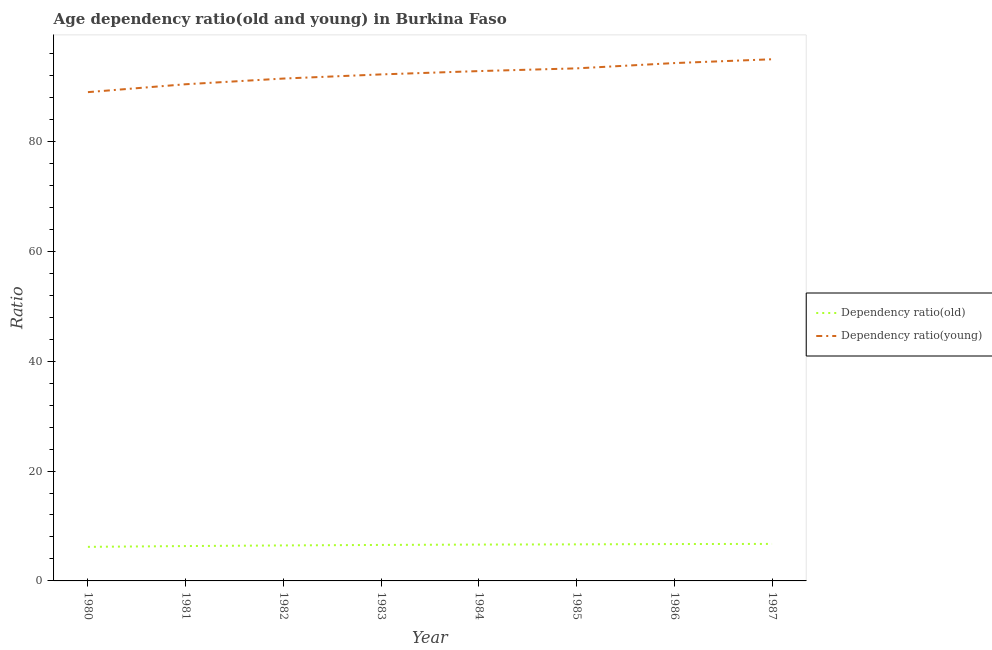Does the line corresponding to age dependency ratio(old) intersect with the line corresponding to age dependency ratio(young)?
Your answer should be very brief. No. Is the number of lines equal to the number of legend labels?
Provide a succinct answer. Yes. What is the age dependency ratio(young) in 1980?
Keep it short and to the point. 88.95. Across all years, what is the maximum age dependency ratio(young)?
Give a very brief answer. 94.94. Across all years, what is the minimum age dependency ratio(young)?
Your answer should be very brief. 88.95. In which year was the age dependency ratio(old) maximum?
Your answer should be very brief. 1987. What is the total age dependency ratio(old) in the graph?
Ensure brevity in your answer.  52.27. What is the difference between the age dependency ratio(young) in 1981 and that in 1984?
Your answer should be compact. -2.4. What is the difference between the age dependency ratio(young) in 1984 and the age dependency ratio(old) in 1987?
Offer a very short reply. 86.05. What is the average age dependency ratio(young) per year?
Your answer should be compact. 92.27. In the year 1980, what is the difference between the age dependency ratio(old) and age dependency ratio(young)?
Your answer should be compact. -82.75. In how many years, is the age dependency ratio(young) greater than 64?
Offer a terse response. 8. What is the ratio of the age dependency ratio(old) in 1983 to that in 1987?
Offer a very short reply. 0.97. Is the age dependency ratio(old) in 1980 less than that in 1984?
Your response must be concise. Yes. What is the difference between the highest and the second highest age dependency ratio(young)?
Your answer should be very brief. 0.69. What is the difference between the highest and the lowest age dependency ratio(young)?
Your answer should be compact. 5.98. In how many years, is the age dependency ratio(old) greater than the average age dependency ratio(old) taken over all years?
Offer a very short reply. 5. Does the age dependency ratio(old) monotonically increase over the years?
Your answer should be very brief. Yes. Is the age dependency ratio(old) strictly greater than the age dependency ratio(young) over the years?
Offer a very short reply. No. How many lines are there?
Offer a terse response. 2. How many years are there in the graph?
Give a very brief answer. 8. Does the graph contain grids?
Provide a short and direct response. No. Where does the legend appear in the graph?
Provide a short and direct response. Center right. How many legend labels are there?
Ensure brevity in your answer.  2. How are the legend labels stacked?
Your answer should be compact. Vertical. What is the title of the graph?
Your answer should be very brief. Age dependency ratio(old and young) in Burkina Faso. Does "GDP" appear as one of the legend labels in the graph?
Provide a succinct answer. No. What is the label or title of the X-axis?
Offer a very short reply. Year. What is the label or title of the Y-axis?
Provide a succinct answer. Ratio. What is the Ratio in Dependency ratio(old) in 1980?
Ensure brevity in your answer.  6.2. What is the Ratio of Dependency ratio(young) in 1980?
Offer a very short reply. 88.95. What is the Ratio in Dependency ratio(old) in 1981?
Your response must be concise. 6.34. What is the Ratio in Dependency ratio(young) in 1981?
Make the answer very short. 90.39. What is the Ratio in Dependency ratio(old) in 1982?
Keep it short and to the point. 6.46. What is the Ratio of Dependency ratio(young) in 1982?
Offer a very short reply. 91.42. What is the Ratio in Dependency ratio(old) in 1983?
Your answer should be very brief. 6.55. What is the Ratio of Dependency ratio(young) in 1983?
Your answer should be compact. 92.18. What is the Ratio of Dependency ratio(old) in 1984?
Keep it short and to the point. 6.61. What is the Ratio of Dependency ratio(young) in 1984?
Make the answer very short. 92.78. What is the Ratio of Dependency ratio(old) in 1985?
Your response must be concise. 6.65. What is the Ratio in Dependency ratio(young) in 1985?
Give a very brief answer. 93.28. What is the Ratio in Dependency ratio(old) in 1986?
Offer a terse response. 6.71. What is the Ratio in Dependency ratio(young) in 1986?
Provide a succinct answer. 94.24. What is the Ratio in Dependency ratio(old) in 1987?
Ensure brevity in your answer.  6.74. What is the Ratio of Dependency ratio(young) in 1987?
Your answer should be compact. 94.94. Across all years, what is the maximum Ratio of Dependency ratio(old)?
Ensure brevity in your answer.  6.74. Across all years, what is the maximum Ratio in Dependency ratio(young)?
Your answer should be compact. 94.94. Across all years, what is the minimum Ratio of Dependency ratio(old)?
Make the answer very short. 6.2. Across all years, what is the minimum Ratio in Dependency ratio(young)?
Provide a succinct answer. 88.95. What is the total Ratio in Dependency ratio(old) in the graph?
Provide a succinct answer. 52.27. What is the total Ratio of Dependency ratio(young) in the graph?
Your answer should be compact. 738.19. What is the difference between the Ratio in Dependency ratio(old) in 1980 and that in 1981?
Offer a very short reply. -0.14. What is the difference between the Ratio in Dependency ratio(young) in 1980 and that in 1981?
Make the answer very short. -1.44. What is the difference between the Ratio in Dependency ratio(old) in 1980 and that in 1982?
Give a very brief answer. -0.26. What is the difference between the Ratio of Dependency ratio(young) in 1980 and that in 1982?
Give a very brief answer. -2.47. What is the difference between the Ratio of Dependency ratio(old) in 1980 and that in 1983?
Provide a succinct answer. -0.35. What is the difference between the Ratio in Dependency ratio(young) in 1980 and that in 1983?
Keep it short and to the point. -3.23. What is the difference between the Ratio in Dependency ratio(old) in 1980 and that in 1984?
Provide a short and direct response. -0.41. What is the difference between the Ratio of Dependency ratio(young) in 1980 and that in 1984?
Keep it short and to the point. -3.83. What is the difference between the Ratio in Dependency ratio(old) in 1980 and that in 1985?
Offer a terse response. -0.45. What is the difference between the Ratio in Dependency ratio(young) in 1980 and that in 1985?
Provide a succinct answer. -4.33. What is the difference between the Ratio in Dependency ratio(old) in 1980 and that in 1986?
Offer a terse response. -0.51. What is the difference between the Ratio of Dependency ratio(young) in 1980 and that in 1986?
Offer a very short reply. -5.29. What is the difference between the Ratio of Dependency ratio(old) in 1980 and that in 1987?
Your answer should be very brief. -0.54. What is the difference between the Ratio of Dependency ratio(young) in 1980 and that in 1987?
Ensure brevity in your answer.  -5.98. What is the difference between the Ratio in Dependency ratio(old) in 1981 and that in 1982?
Your answer should be compact. -0.12. What is the difference between the Ratio in Dependency ratio(young) in 1981 and that in 1982?
Provide a succinct answer. -1.04. What is the difference between the Ratio in Dependency ratio(old) in 1981 and that in 1983?
Provide a succinct answer. -0.21. What is the difference between the Ratio in Dependency ratio(young) in 1981 and that in 1983?
Offer a very short reply. -1.79. What is the difference between the Ratio of Dependency ratio(old) in 1981 and that in 1984?
Your response must be concise. -0.27. What is the difference between the Ratio of Dependency ratio(young) in 1981 and that in 1984?
Offer a very short reply. -2.4. What is the difference between the Ratio in Dependency ratio(old) in 1981 and that in 1985?
Your answer should be compact. -0.31. What is the difference between the Ratio of Dependency ratio(young) in 1981 and that in 1985?
Provide a short and direct response. -2.89. What is the difference between the Ratio of Dependency ratio(old) in 1981 and that in 1986?
Your answer should be compact. -0.37. What is the difference between the Ratio in Dependency ratio(young) in 1981 and that in 1986?
Keep it short and to the point. -3.85. What is the difference between the Ratio in Dependency ratio(old) in 1981 and that in 1987?
Provide a succinct answer. -0.39. What is the difference between the Ratio in Dependency ratio(young) in 1981 and that in 1987?
Provide a succinct answer. -4.55. What is the difference between the Ratio of Dependency ratio(old) in 1982 and that in 1983?
Offer a terse response. -0.09. What is the difference between the Ratio in Dependency ratio(young) in 1982 and that in 1983?
Make the answer very short. -0.76. What is the difference between the Ratio in Dependency ratio(old) in 1982 and that in 1984?
Your response must be concise. -0.15. What is the difference between the Ratio of Dependency ratio(young) in 1982 and that in 1984?
Your answer should be very brief. -1.36. What is the difference between the Ratio of Dependency ratio(old) in 1982 and that in 1985?
Provide a short and direct response. -0.19. What is the difference between the Ratio of Dependency ratio(young) in 1982 and that in 1985?
Offer a very short reply. -1.86. What is the difference between the Ratio of Dependency ratio(old) in 1982 and that in 1986?
Offer a very short reply. -0.25. What is the difference between the Ratio in Dependency ratio(young) in 1982 and that in 1986?
Give a very brief answer. -2.82. What is the difference between the Ratio of Dependency ratio(old) in 1982 and that in 1987?
Offer a very short reply. -0.28. What is the difference between the Ratio of Dependency ratio(young) in 1982 and that in 1987?
Offer a terse response. -3.51. What is the difference between the Ratio of Dependency ratio(old) in 1983 and that in 1984?
Give a very brief answer. -0.06. What is the difference between the Ratio of Dependency ratio(young) in 1983 and that in 1984?
Provide a succinct answer. -0.6. What is the difference between the Ratio of Dependency ratio(old) in 1983 and that in 1985?
Your answer should be compact. -0.11. What is the difference between the Ratio of Dependency ratio(young) in 1983 and that in 1985?
Your answer should be very brief. -1.1. What is the difference between the Ratio of Dependency ratio(old) in 1983 and that in 1986?
Provide a short and direct response. -0.16. What is the difference between the Ratio in Dependency ratio(young) in 1983 and that in 1986?
Ensure brevity in your answer.  -2.06. What is the difference between the Ratio in Dependency ratio(old) in 1983 and that in 1987?
Make the answer very short. -0.19. What is the difference between the Ratio of Dependency ratio(young) in 1983 and that in 1987?
Your answer should be compact. -2.76. What is the difference between the Ratio of Dependency ratio(old) in 1984 and that in 1985?
Your answer should be very brief. -0.04. What is the difference between the Ratio of Dependency ratio(young) in 1984 and that in 1985?
Give a very brief answer. -0.5. What is the difference between the Ratio in Dependency ratio(old) in 1984 and that in 1986?
Your answer should be compact. -0.1. What is the difference between the Ratio of Dependency ratio(young) in 1984 and that in 1986?
Offer a terse response. -1.46. What is the difference between the Ratio in Dependency ratio(old) in 1984 and that in 1987?
Give a very brief answer. -0.12. What is the difference between the Ratio in Dependency ratio(young) in 1984 and that in 1987?
Ensure brevity in your answer.  -2.15. What is the difference between the Ratio of Dependency ratio(old) in 1985 and that in 1986?
Offer a terse response. -0.06. What is the difference between the Ratio of Dependency ratio(young) in 1985 and that in 1986?
Offer a terse response. -0.96. What is the difference between the Ratio of Dependency ratio(old) in 1985 and that in 1987?
Give a very brief answer. -0.08. What is the difference between the Ratio of Dependency ratio(young) in 1985 and that in 1987?
Make the answer very short. -1.66. What is the difference between the Ratio of Dependency ratio(old) in 1986 and that in 1987?
Provide a succinct answer. -0.03. What is the difference between the Ratio in Dependency ratio(young) in 1986 and that in 1987?
Provide a short and direct response. -0.69. What is the difference between the Ratio of Dependency ratio(old) in 1980 and the Ratio of Dependency ratio(young) in 1981?
Make the answer very short. -84.19. What is the difference between the Ratio of Dependency ratio(old) in 1980 and the Ratio of Dependency ratio(young) in 1982?
Make the answer very short. -85.22. What is the difference between the Ratio of Dependency ratio(old) in 1980 and the Ratio of Dependency ratio(young) in 1983?
Give a very brief answer. -85.98. What is the difference between the Ratio in Dependency ratio(old) in 1980 and the Ratio in Dependency ratio(young) in 1984?
Your answer should be compact. -86.58. What is the difference between the Ratio in Dependency ratio(old) in 1980 and the Ratio in Dependency ratio(young) in 1985?
Ensure brevity in your answer.  -87.08. What is the difference between the Ratio of Dependency ratio(old) in 1980 and the Ratio of Dependency ratio(young) in 1986?
Ensure brevity in your answer.  -88.04. What is the difference between the Ratio of Dependency ratio(old) in 1980 and the Ratio of Dependency ratio(young) in 1987?
Provide a short and direct response. -88.74. What is the difference between the Ratio in Dependency ratio(old) in 1981 and the Ratio in Dependency ratio(young) in 1982?
Your answer should be compact. -85.08. What is the difference between the Ratio of Dependency ratio(old) in 1981 and the Ratio of Dependency ratio(young) in 1983?
Offer a terse response. -85.84. What is the difference between the Ratio in Dependency ratio(old) in 1981 and the Ratio in Dependency ratio(young) in 1984?
Keep it short and to the point. -86.44. What is the difference between the Ratio in Dependency ratio(old) in 1981 and the Ratio in Dependency ratio(young) in 1985?
Your answer should be very brief. -86.94. What is the difference between the Ratio in Dependency ratio(old) in 1981 and the Ratio in Dependency ratio(young) in 1986?
Make the answer very short. -87.9. What is the difference between the Ratio of Dependency ratio(old) in 1981 and the Ratio of Dependency ratio(young) in 1987?
Give a very brief answer. -88.59. What is the difference between the Ratio of Dependency ratio(old) in 1982 and the Ratio of Dependency ratio(young) in 1983?
Keep it short and to the point. -85.72. What is the difference between the Ratio in Dependency ratio(old) in 1982 and the Ratio in Dependency ratio(young) in 1984?
Provide a succinct answer. -86.32. What is the difference between the Ratio in Dependency ratio(old) in 1982 and the Ratio in Dependency ratio(young) in 1985?
Ensure brevity in your answer.  -86.82. What is the difference between the Ratio of Dependency ratio(old) in 1982 and the Ratio of Dependency ratio(young) in 1986?
Your answer should be compact. -87.78. What is the difference between the Ratio in Dependency ratio(old) in 1982 and the Ratio in Dependency ratio(young) in 1987?
Your answer should be very brief. -88.48. What is the difference between the Ratio of Dependency ratio(old) in 1983 and the Ratio of Dependency ratio(young) in 1984?
Your answer should be compact. -86.24. What is the difference between the Ratio of Dependency ratio(old) in 1983 and the Ratio of Dependency ratio(young) in 1985?
Provide a succinct answer. -86.73. What is the difference between the Ratio in Dependency ratio(old) in 1983 and the Ratio in Dependency ratio(young) in 1986?
Provide a short and direct response. -87.69. What is the difference between the Ratio of Dependency ratio(old) in 1983 and the Ratio of Dependency ratio(young) in 1987?
Your response must be concise. -88.39. What is the difference between the Ratio in Dependency ratio(old) in 1984 and the Ratio in Dependency ratio(young) in 1985?
Keep it short and to the point. -86.67. What is the difference between the Ratio of Dependency ratio(old) in 1984 and the Ratio of Dependency ratio(young) in 1986?
Make the answer very short. -87.63. What is the difference between the Ratio in Dependency ratio(old) in 1984 and the Ratio in Dependency ratio(young) in 1987?
Your answer should be very brief. -88.32. What is the difference between the Ratio of Dependency ratio(old) in 1985 and the Ratio of Dependency ratio(young) in 1986?
Make the answer very short. -87.59. What is the difference between the Ratio of Dependency ratio(old) in 1985 and the Ratio of Dependency ratio(young) in 1987?
Make the answer very short. -88.28. What is the difference between the Ratio in Dependency ratio(old) in 1986 and the Ratio in Dependency ratio(young) in 1987?
Your answer should be very brief. -88.23. What is the average Ratio of Dependency ratio(old) per year?
Ensure brevity in your answer.  6.53. What is the average Ratio in Dependency ratio(young) per year?
Provide a short and direct response. 92.27. In the year 1980, what is the difference between the Ratio in Dependency ratio(old) and Ratio in Dependency ratio(young)?
Offer a terse response. -82.75. In the year 1981, what is the difference between the Ratio of Dependency ratio(old) and Ratio of Dependency ratio(young)?
Provide a short and direct response. -84.04. In the year 1982, what is the difference between the Ratio in Dependency ratio(old) and Ratio in Dependency ratio(young)?
Your answer should be compact. -84.96. In the year 1983, what is the difference between the Ratio in Dependency ratio(old) and Ratio in Dependency ratio(young)?
Your answer should be compact. -85.63. In the year 1984, what is the difference between the Ratio of Dependency ratio(old) and Ratio of Dependency ratio(young)?
Keep it short and to the point. -86.17. In the year 1985, what is the difference between the Ratio in Dependency ratio(old) and Ratio in Dependency ratio(young)?
Provide a short and direct response. -86.63. In the year 1986, what is the difference between the Ratio in Dependency ratio(old) and Ratio in Dependency ratio(young)?
Give a very brief answer. -87.53. In the year 1987, what is the difference between the Ratio in Dependency ratio(old) and Ratio in Dependency ratio(young)?
Offer a terse response. -88.2. What is the ratio of the Ratio in Dependency ratio(old) in 1980 to that in 1981?
Provide a succinct answer. 0.98. What is the ratio of the Ratio in Dependency ratio(young) in 1980 to that in 1981?
Offer a very short reply. 0.98. What is the ratio of the Ratio of Dependency ratio(old) in 1980 to that in 1982?
Keep it short and to the point. 0.96. What is the ratio of the Ratio of Dependency ratio(young) in 1980 to that in 1982?
Offer a very short reply. 0.97. What is the ratio of the Ratio of Dependency ratio(old) in 1980 to that in 1983?
Provide a succinct answer. 0.95. What is the ratio of the Ratio of Dependency ratio(young) in 1980 to that in 1983?
Your response must be concise. 0.96. What is the ratio of the Ratio in Dependency ratio(old) in 1980 to that in 1984?
Offer a very short reply. 0.94. What is the ratio of the Ratio in Dependency ratio(young) in 1980 to that in 1984?
Your answer should be compact. 0.96. What is the ratio of the Ratio of Dependency ratio(old) in 1980 to that in 1985?
Offer a very short reply. 0.93. What is the ratio of the Ratio of Dependency ratio(young) in 1980 to that in 1985?
Give a very brief answer. 0.95. What is the ratio of the Ratio of Dependency ratio(old) in 1980 to that in 1986?
Keep it short and to the point. 0.92. What is the ratio of the Ratio in Dependency ratio(young) in 1980 to that in 1986?
Make the answer very short. 0.94. What is the ratio of the Ratio of Dependency ratio(old) in 1980 to that in 1987?
Offer a very short reply. 0.92. What is the ratio of the Ratio of Dependency ratio(young) in 1980 to that in 1987?
Give a very brief answer. 0.94. What is the ratio of the Ratio in Dependency ratio(old) in 1981 to that in 1982?
Offer a very short reply. 0.98. What is the ratio of the Ratio in Dependency ratio(young) in 1981 to that in 1982?
Ensure brevity in your answer.  0.99. What is the ratio of the Ratio in Dependency ratio(old) in 1981 to that in 1983?
Keep it short and to the point. 0.97. What is the ratio of the Ratio in Dependency ratio(young) in 1981 to that in 1983?
Keep it short and to the point. 0.98. What is the ratio of the Ratio in Dependency ratio(old) in 1981 to that in 1984?
Make the answer very short. 0.96. What is the ratio of the Ratio of Dependency ratio(young) in 1981 to that in 1984?
Make the answer very short. 0.97. What is the ratio of the Ratio of Dependency ratio(old) in 1981 to that in 1985?
Your answer should be compact. 0.95. What is the ratio of the Ratio of Dependency ratio(old) in 1981 to that in 1986?
Offer a very short reply. 0.95. What is the ratio of the Ratio in Dependency ratio(young) in 1981 to that in 1986?
Ensure brevity in your answer.  0.96. What is the ratio of the Ratio in Dependency ratio(old) in 1981 to that in 1987?
Give a very brief answer. 0.94. What is the ratio of the Ratio of Dependency ratio(young) in 1981 to that in 1987?
Keep it short and to the point. 0.95. What is the ratio of the Ratio of Dependency ratio(old) in 1982 to that in 1983?
Offer a terse response. 0.99. What is the ratio of the Ratio of Dependency ratio(young) in 1982 to that in 1983?
Make the answer very short. 0.99. What is the ratio of the Ratio in Dependency ratio(old) in 1982 to that in 1984?
Offer a very short reply. 0.98. What is the ratio of the Ratio in Dependency ratio(young) in 1982 to that in 1984?
Your answer should be very brief. 0.99. What is the ratio of the Ratio in Dependency ratio(old) in 1982 to that in 1985?
Your answer should be compact. 0.97. What is the ratio of the Ratio of Dependency ratio(young) in 1982 to that in 1985?
Your answer should be very brief. 0.98. What is the ratio of the Ratio in Dependency ratio(old) in 1982 to that in 1986?
Offer a very short reply. 0.96. What is the ratio of the Ratio in Dependency ratio(young) in 1982 to that in 1986?
Offer a very short reply. 0.97. What is the ratio of the Ratio of Dependency ratio(old) in 1982 to that in 1987?
Offer a very short reply. 0.96. What is the ratio of the Ratio of Dependency ratio(old) in 1983 to that in 1984?
Your answer should be very brief. 0.99. What is the ratio of the Ratio of Dependency ratio(old) in 1983 to that in 1985?
Your answer should be compact. 0.98. What is the ratio of the Ratio in Dependency ratio(young) in 1983 to that in 1985?
Offer a terse response. 0.99. What is the ratio of the Ratio in Dependency ratio(young) in 1983 to that in 1986?
Your answer should be very brief. 0.98. What is the ratio of the Ratio in Dependency ratio(old) in 1983 to that in 1987?
Offer a terse response. 0.97. What is the ratio of the Ratio of Dependency ratio(young) in 1983 to that in 1987?
Ensure brevity in your answer.  0.97. What is the ratio of the Ratio in Dependency ratio(old) in 1984 to that in 1985?
Offer a very short reply. 0.99. What is the ratio of the Ratio in Dependency ratio(old) in 1984 to that in 1986?
Your answer should be compact. 0.99. What is the ratio of the Ratio of Dependency ratio(young) in 1984 to that in 1986?
Your response must be concise. 0.98. What is the ratio of the Ratio of Dependency ratio(old) in 1984 to that in 1987?
Give a very brief answer. 0.98. What is the ratio of the Ratio of Dependency ratio(young) in 1984 to that in 1987?
Provide a short and direct response. 0.98. What is the ratio of the Ratio in Dependency ratio(old) in 1985 to that in 1986?
Ensure brevity in your answer.  0.99. What is the ratio of the Ratio in Dependency ratio(young) in 1985 to that in 1986?
Your response must be concise. 0.99. What is the ratio of the Ratio in Dependency ratio(old) in 1985 to that in 1987?
Your answer should be very brief. 0.99. What is the ratio of the Ratio of Dependency ratio(young) in 1985 to that in 1987?
Your answer should be compact. 0.98. What is the ratio of the Ratio in Dependency ratio(old) in 1986 to that in 1987?
Your response must be concise. 1. What is the ratio of the Ratio in Dependency ratio(young) in 1986 to that in 1987?
Make the answer very short. 0.99. What is the difference between the highest and the second highest Ratio in Dependency ratio(old)?
Offer a terse response. 0.03. What is the difference between the highest and the second highest Ratio of Dependency ratio(young)?
Your response must be concise. 0.69. What is the difference between the highest and the lowest Ratio of Dependency ratio(old)?
Offer a terse response. 0.54. What is the difference between the highest and the lowest Ratio of Dependency ratio(young)?
Give a very brief answer. 5.98. 